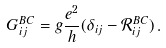Convert formula to latex. <formula><loc_0><loc_0><loc_500><loc_500>G ^ { B C } _ { i j } = g \frac { e ^ { 2 } } { h } ( \delta _ { i j } - \mathcal { R } ^ { B C } _ { i j } ) \, .</formula> 